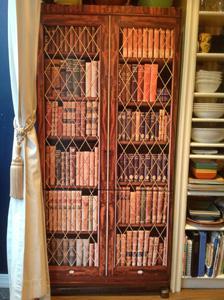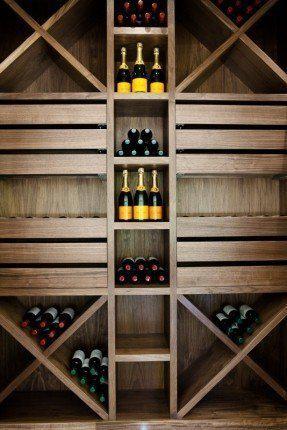The first image is the image on the left, the second image is the image on the right. Considering the images on both sides, is "In one image there are books on a bookshelf locked up behind glass." valid? Answer yes or no. Yes. The first image is the image on the left, the second image is the image on the right. For the images displayed, is the sentence "there is a room with a bookshelf made of dark wood and a leather sofa in front of it" factually correct? Answer yes or no. No. 